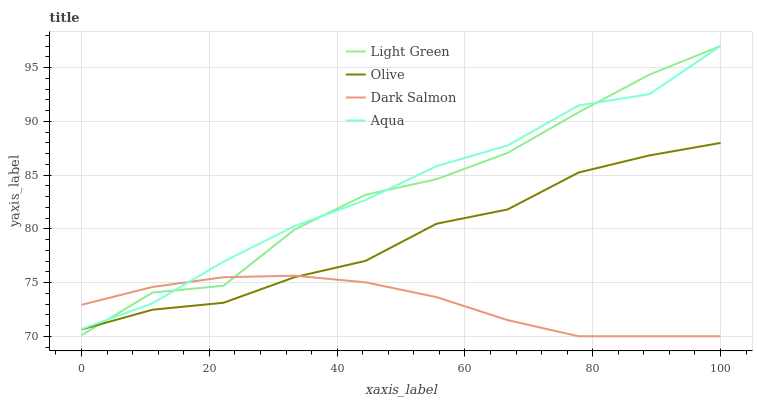Does Aqua have the minimum area under the curve?
Answer yes or no. No. Does Dark Salmon have the maximum area under the curve?
Answer yes or no. No. Is Aqua the smoothest?
Answer yes or no. No. Is Aqua the roughest?
Answer yes or no. No. Does Aqua have the lowest value?
Answer yes or no. No. Does Dark Salmon have the highest value?
Answer yes or no. No. Is Olive less than Aqua?
Answer yes or no. Yes. Is Aqua greater than Olive?
Answer yes or no. Yes. Does Olive intersect Aqua?
Answer yes or no. No. 